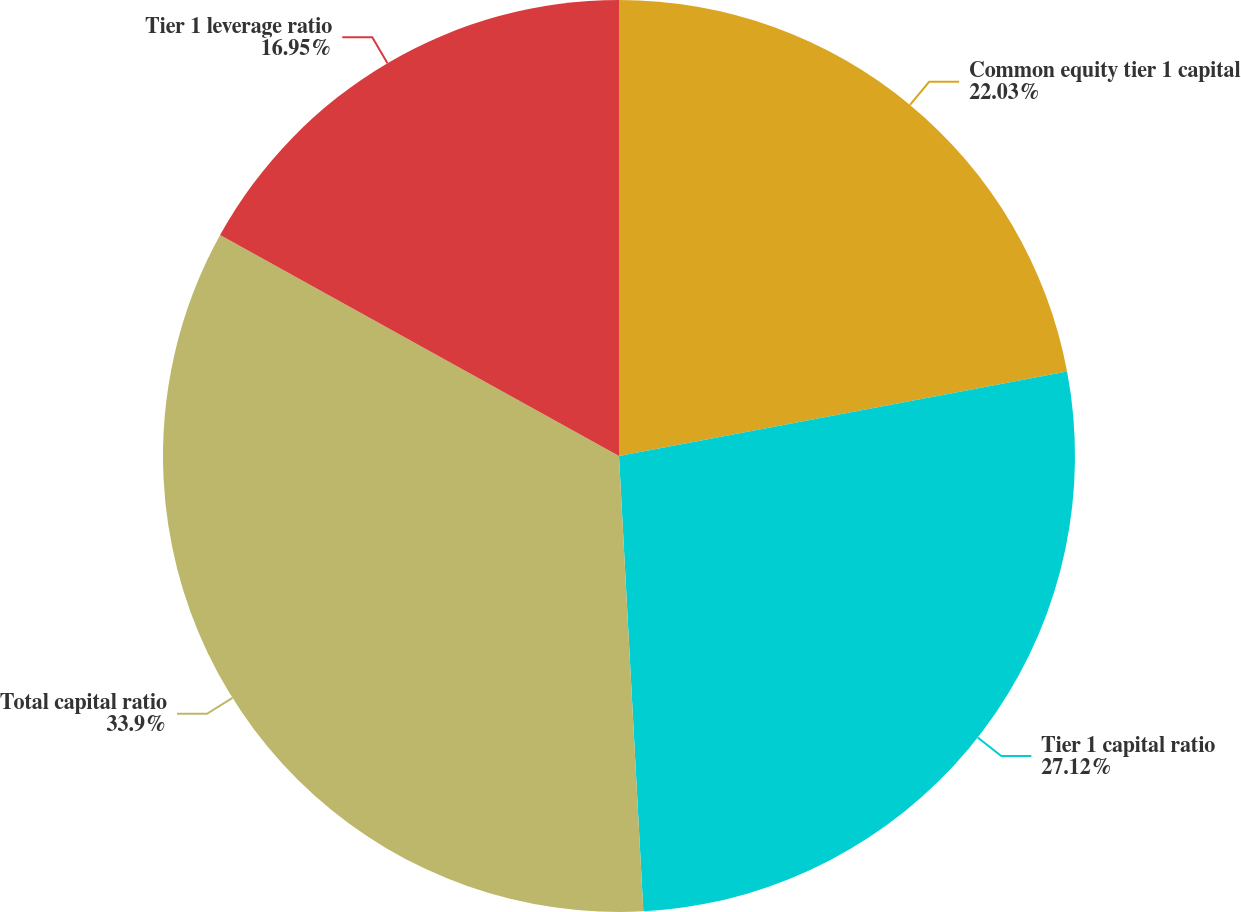<chart> <loc_0><loc_0><loc_500><loc_500><pie_chart><fcel>Common equity tier 1 capital<fcel>Tier 1 capital ratio<fcel>Total capital ratio<fcel>Tier 1 leverage ratio<nl><fcel>22.03%<fcel>27.12%<fcel>33.9%<fcel>16.95%<nl></chart> 